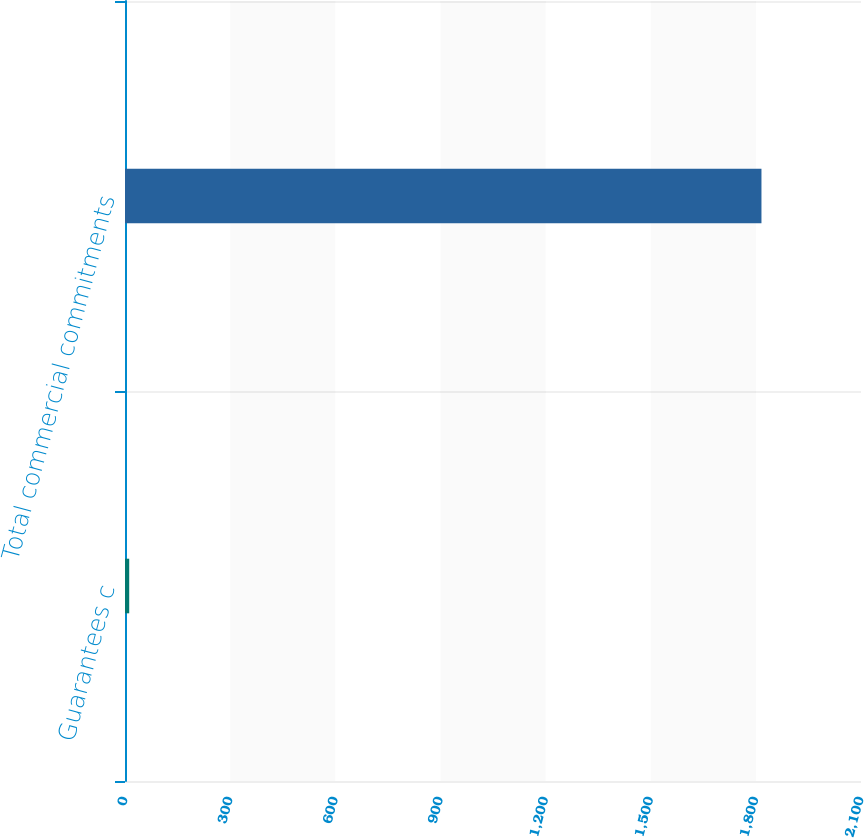<chart> <loc_0><loc_0><loc_500><loc_500><bar_chart><fcel>Guarantees c<fcel>Total commercial commitments<nl><fcel>12<fcel>1816<nl></chart> 